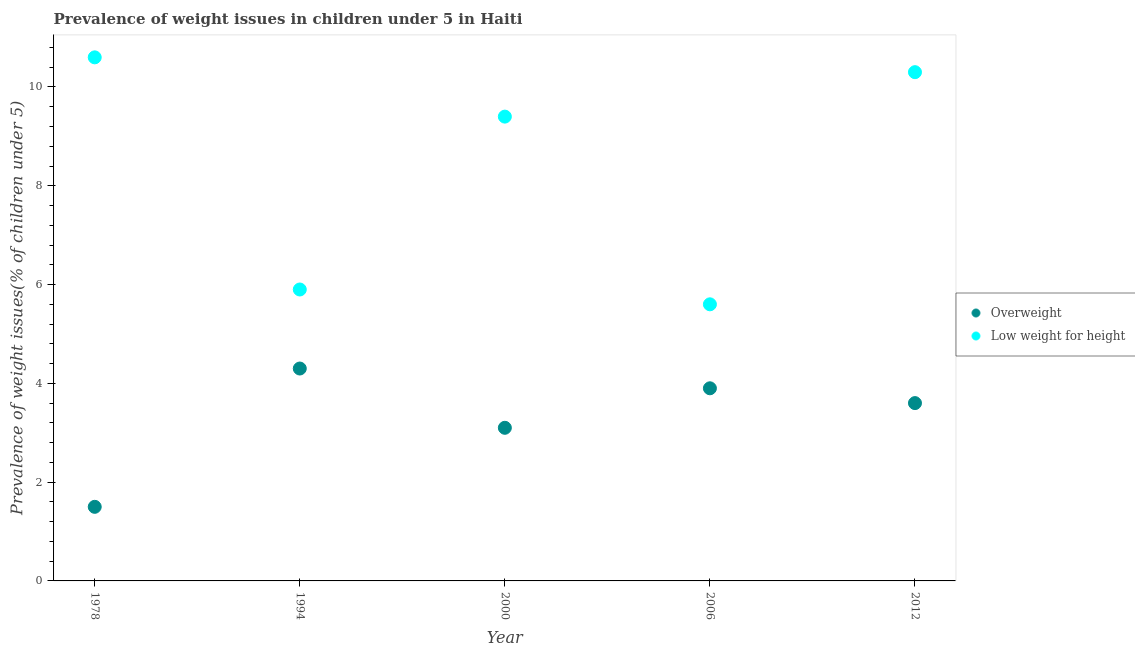How many different coloured dotlines are there?
Your response must be concise. 2. Is the number of dotlines equal to the number of legend labels?
Provide a short and direct response. Yes. Across all years, what is the maximum percentage of overweight children?
Ensure brevity in your answer.  4.3. Across all years, what is the minimum percentage of underweight children?
Keep it short and to the point. 5.6. In which year was the percentage of overweight children minimum?
Make the answer very short. 1978. What is the total percentage of underweight children in the graph?
Ensure brevity in your answer.  41.8. What is the difference between the percentage of underweight children in 1994 and that in 2000?
Provide a short and direct response. -3.5. What is the difference between the percentage of overweight children in 2006 and the percentage of underweight children in 2000?
Offer a very short reply. -5.5. What is the average percentage of overweight children per year?
Your response must be concise. 3.28. In the year 2012, what is the difference between the percentage of overweight children and percentage of underweight children?
Keep it short and to the point. -6.7. What is the ratio of the percentage of underweight children in 1978 to that in 2006?
Provide a short and direct response. 1.89. Is the percentage of overweight children in 2000 less than that in 2012?
Make the answer very short. Yes. Is the difference between the percentage of underweight children in 1994 and 2006 greater than the difference between the percentage of overweight children in 1994 and 2006?
Your answer should be compact. No. What is the difference between the highest and the second highest percentage of underweight children?
Offer a very short reply. 0.3. What is the difference between the highest and the lowest percentage of overweight children?
Your answer should be compact. 2.8. Does the percentage of underweight children monotonically increase over the years?
Keep it short and to the point. No. Is the percentage of underweight children strictly greater than the percentage of overweight children over the years?
Offer a terse response. Yes. Is the percentage of underweight children strictly less than the percentage of overweight children over the years?
Your response must be concise. No. How many years are there in the graph?
Provide a short and direct response. 5. What is the difference between two consecutive major ticks on the Y-axis?
Provide a succinct answer. 2. Are the values on the major ticks of Y-axis written in scientific E-notation?
Provide a short and direct response. No. Does the graph contain any zero values?
Provide a succinct answer. No. Where does the legend appear in the graph?
Provide a short and direct response. Center right. What is the title of the graph?
Offer a very short reply. Prevalence of weight issues in children under 5 in Haiti. Does "From human activities" appear as one of the legend labels in the graph?
Offer a very short reply. No. What is the label or title of the X-axis?
Make the answer very short. Year. What is the label or title of the Y-axis?
Your response must be concise. Prevalence of weight issues(% of children under 5). What is the Prevalence of weight issues(% of children under 5) in Low weight for height in 1978?
Keep it short and to the point. 10.6. What is the Prevalence of weight issues(% of children under 5) in Overweight in 1994?
Your answer should be compact. 4.3. What is the Prevalence of weight issues(% of children under 5) in Low weight for height in 1994?
Provide a short and direct response. 5.9. What is the Prevalence of weight issues(% of children under 5) of Overweight in 2000?
Offer a terse response. 3.1. What is the Prevalence of weight issues(% of children under 5) of Low weight for height in 2000?
Keep it short and to the point. 9.4. What is the Prevalence of weight issues(% of children under 5) in Overweight in 2006?
Keep it short and to the point. 3.9. What is the Prevalence of weight issues(% of children under 5) of Low weight for height in 2006?
Give a very brief answer. 5.6. What is the Prevalence of weight issues(% of children under 5) of Overweight in 2012?
Offer a terse response. 3.6. What is the Prevalence of weight issues(% of children under 5) in Low weight for height in 2012?
Offer a terse response. 10.3. Across all years, what is the maximum Prevalence of weight issues(% of children under 5) in Overweight?
Offer a terse response. 4.3. Across all years, what is the maximum Prevalence of weight issues(% of children under 5) of Low weight for height?
Offer a terse response. 10.6. Across all years, what is the minimum Prevalence of weight issues(% of children under 5) of Overweight?
Your response must be concise. 1.5. Across all years, what is the minimum Prevalence of weight issues(% of children under 5) of Low weight for height?
Offer a very short reply. 5.6. What is the total Prevalence of weight issues(% of children under 5) in Low weight for height in the graph?
Provide a short and direct response. 41.8. What is the difference between the Prevalence of weight issues(% of children under 5) of Low weight for height in 1978 and that in 1994?
Keep it short and to the point. 4.7. What is the difference between the Prevalence of weight issues(% of children under 5) in Low weight for height in 1978 and that in 2000?
Offer a very short reply. 1.2. What is the difference between the Prevalence of weight issues(% of children under 5) of Overweight in 1978 and that in 2006?
Your response must be concise. -2.4. What is the difference between the Prevalence of weight issues(% of children under 5) in Overweight in 1978 and that in 2012?
Offer a terse response. -2.1. What is the difference between the Prevalence of weight issues(% of children under 5) in Low weight for height in 1978 and that in 2012?
Your answer should be very brief. 0.3. What is the difference between the Prevalence of weight issues(% of children under 5) of Overweight in 1994 and that in 2000?
Provide a short and direct response. 1.2. What is the difference between the Prevalence of weight issues(% of children under 5) in Low weight for height in 1994 and that in 2000?
Your answer should be compact. -3.5. What is the difference between the Prevalence of weight issues(% of children under 5) of Overweight in 1994 and that in 2006?
Ensure brevity in your answer.  0.4. What is the difference between the Prevalence of weight issues(% of children under 5) of Low weight for height in 1994 and that in 2012?
Keep it short and to the point. -4.4. What is the difference between the Prevalence of weight issues(% of children under 5) of Low weight for height in 2000 and that in 2006?
Provide a short and direct response. 3.8. What is the difference between the Prevalence of weight issues(% of children under 5) in Overweight in 1978 and the Prevalence of weight issues(% of children under 5) in Low weight for height in 1994?
Your answer should be compact. -4.4. What is the difference between the Prevalence of weight issues(% of children under 5) in Overweight in 1978 and the Prevalence of weight issues(% of children under 5) in Low weight for height in 2006?
Provide a short and direct response. -4.1. What is the difference between the Prevalence of weight issues(% of children under 5) in Overweight in 1994 and the Prevalence of weight issues(% of children under 5) in Low weight for height in 2006?
Offer a very short reply. -1.3. What is the difference between the Prevalence of weight issues(% of children under 5) of Overweight in 2006 and the Prevalence of weight issues(% of children under 5) of Low weight for height in 2012?
Give a very brief answer. -6.4. What is the average Prevalence of weight issues(% of children under 5) of Overweight per year?
Offer a very short reply. 3.28. What is the average Prevalence of weight issues(% of children under 5) of Low weight for height per year?
Keep it short and to the point. 8.36. In the year 1978, what is the difference between the Prevalence of weight issues(% of children under 5) in Overweight and Prevalence of weight issues(% of children under 5) in Low weight for height?
Your answer should be compact. -9.1. In the year 2000, what is the difference between the Prevalence of weight issues(% of children under 5) in Overweight and Prevalence of weight issues(% of children under 5) in Low weight for height?
Provide a short and direct response. -6.3. In the year 2006, what is the difference between the Prevalence of weight issues(% of children under 5) in Overweight and Prevalence of weight issues(% of children under 5) in Low weight for height?
Offer a terse response. -1.7. In the year 2012, what is the difference between the Prevalence of weight issues(% of children under 5) in Overweight and Prevalence of weight issues(% of children under 5) in Low weight for height?
Provide a succinct answer. -6.7. What is the ratio of the Prevalence of weight issues(% of children under 5) in Overweight in 1978 to that in 1994?
Provide a short and direct response. 0.35. What is the ratio of the Prevalence of weight issues(% of children under 5) in Low weight for height in 1978 to that in 1994?
Provide a short and direct response. 1.8. What is the ratio of the Prevalence of weight issues(% of children under 5) in Overweight in 1978 to that in 2000?
Your answer should be compact. 0.48. What is the ratio of the Prevalence of weight issues(% of children under 5) of Low weight for height in 1978 to that in 2000?
Your answer should be compact. 1.13. What is the ratio of the Prevalence of weight issues(% of children under 5) in Overweight in 1978 to that in 2006?
Ensure brevity in your answer.  0.38. What is the ratio of the Prevalence of weight issues(% of children under 5) in Low weight for height in 1978 to that in 2006?
Ensure brevity in your answer.  1.89. What is the ratio of the Prevalence of weight issues(% of children under 5) in Overweight in 1978 to that in 2012?
Your response must be concise. 0.42. What is the ratio of the Prevalence of weight issues(% of children under 5) of Low weight for height in 1978 to that in 2012?
Provide a short and direct response. 1.03. What is the ratio of the Prevalence of weight issues(% of children under 5) in Overweight in 1994 to that in 2000?
Provide a succinct answer. 1.39. What is the ratio of the Prevalence of weight issues(% of children under 5) of Low weight for height in 1994 to that in 2000?
Make the answer very short. 0.63. What is the ratio of the Prevalence of weight issues(% of children under 5) in Overweight in 1994 to that in 2006?
Your answer should be very brief. 1.1. What is the ratio of the Prevalence of weight issues(% of children under 5) in Low weight for height in 1994 to that in 2006?
Your response must be concise. 1.05. What is the ratio of the Prevalence of weight issues(% of children under 5) of Overweight in 1994 to that in 2012?
Offer a very short reply. 1.19. What is the ratio of the Prevalence of weight issues(% of children under 5) in Low weight for height in 1994 to that in 2012?
Give a very brief answer. 0.57. What is the ratio of the Prevalence of weight issues(% of children under 5) in Overweight in 2000 to that in 2006?
Your answer should be compact. 0.79. What is the ratio of the Prevalence of weight issues(% of children under 5) in Low weight for height in 2000 to that in 2006?
Your answer should be very brief. 1.68. What is the ratio of the Prevalence of weight issues(% of children under 5) of Overweight in 2000 to that in 2012?
Offer a terse response. 0.86. What is the ratio of the Prevalence of weight issues(% of children under 5) in Low weight for height in 2000 to that in 2012?
Offer a terse response. 0.91. What is the ratio of the Prevalence of weight issues(% of children under 5) in Low weight for height in 2006 to that in 2012?
Provide a short and direct response. 0.54. What is the difference between the highest and the second highest Prevalence of weight issues(% of children under 5) in Overweight?
Offer a very short reply. 0.4. What is the difference between the highest and the second highest Prevalence of weight issues(% of children under 5) in Low weight for height?
Offer a very short reply. 0.3. What is the difference between the highest and the lowest Prevalence of weight issues(% of children under 5) of Overweight?
Your response must be concise. 2.8. What is the difference between the highest and the lowest Prevalence of weight issues(% of children under 5) of Low weight for height?
Offer a very short reply. 5. 